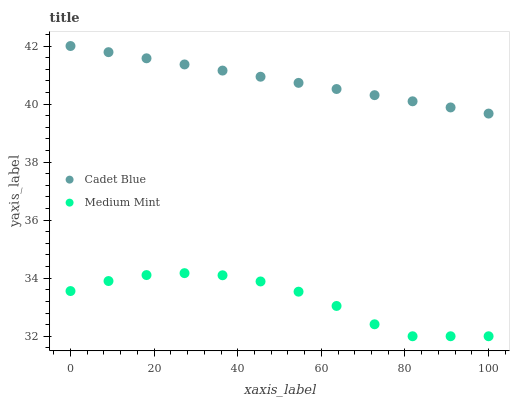Does Medium Mint have the minimum area under the curve?
Answer yes or no. Yes. Does Cadet Blue have the maximum area under the curve?
Answer yes or no. Yes. Does Cadet Blue have the minimum area under the curve?
Answer yes or no. No. Is Cadet Blue the smoothest?
Answer yes or no. Yes. Is Medium Mint the roughest?
Answer yes or no. Yes. Is Cadet Blue the roughest?
Answer yes or no. No. Does Medium Mint have the lowest value?
Answer yes or no. Yes. Does Cadet Blue have the lowest value?
Answer yes or no. No. Does Cadet Blue have the highest value?
Answer yes or no. Yes. Is Medium Mint less than Cadet Blue?
Answer yes or no. Yes. Is Cadet Blue greater than Medium Mint?
Answer yes or no. Yes. Does Medium Mint intersect Cadet Blue?
Answer yes or no. No. 